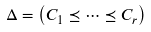<formula> <loc_0><loc_0><loc_500><loc_500>\Delta = \left ( C _ { 1 } \preceq \cdots \preceq C _ { r } \right )</formula> 